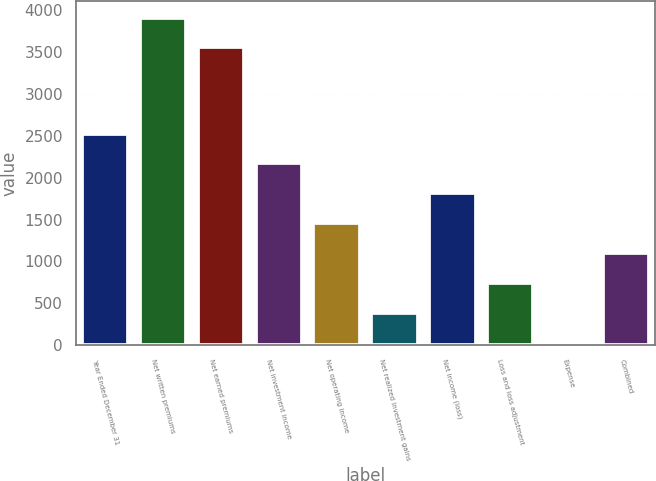Convert chart to OTSL. <chart><loc_0><loc_0><loc_500><loc_500><bar_chart><fcel>Year Ended December 31<fcel>Net written premiums<fcel>Net earned premiums<fcel>Net investment income<fcel>Net operating income<fcel>Net realized investment gains<fcel>Net income (loss)<fcel>Loss and loss adjustment<fcel>Expense<fcel>Combined<nl><fcel>2528.08<fcel>3913.64<fcel>3557<fcel>2171.44<fcel>1458.16<fcel>388.24<fcel>1814.8<fcel>744.88<fcel>31.6<fcel>1101.52<nl></chart> 